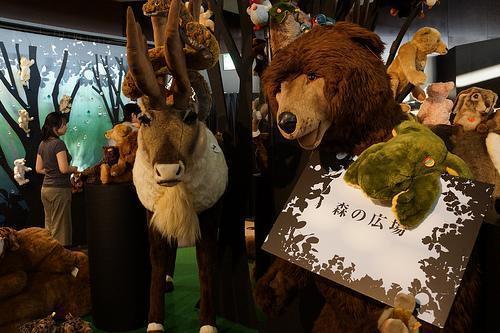How many humans are shown?
Give a very brief answer. 1. How many black tigers are there?
Give a very brief answer. 0. 